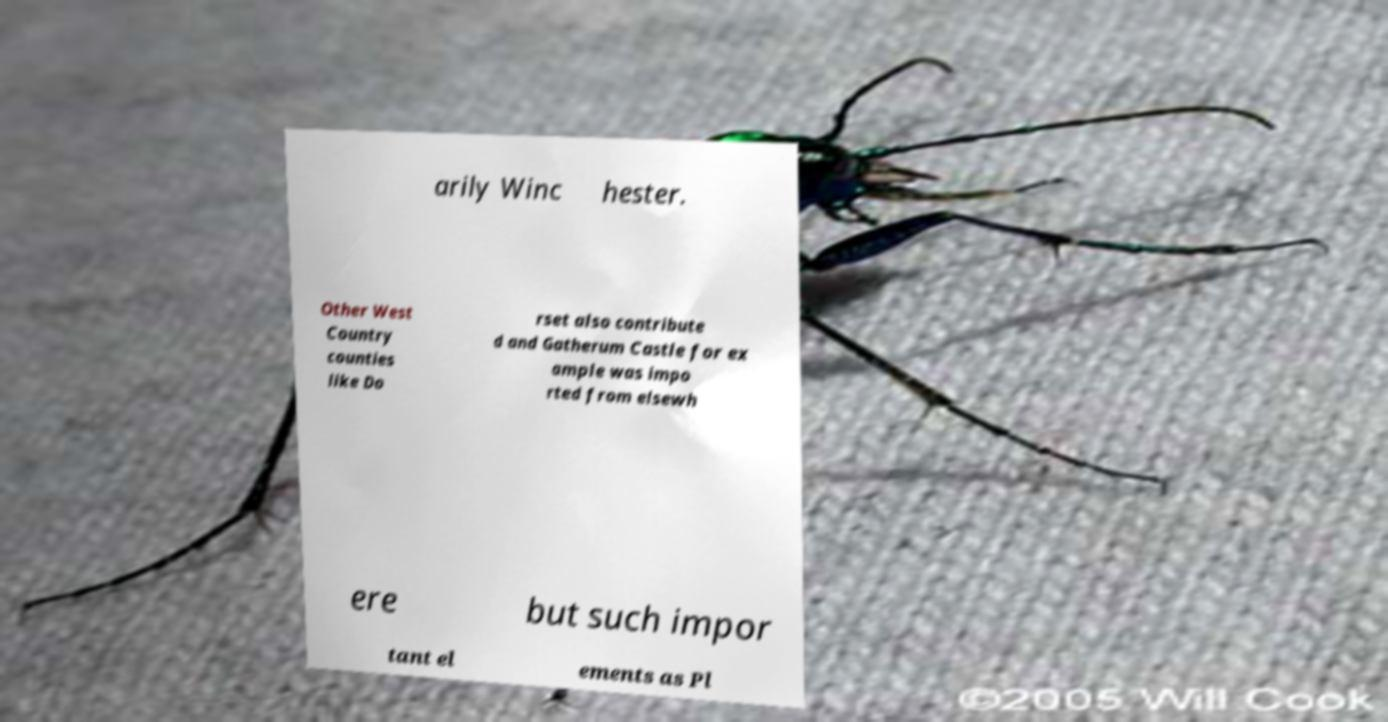Can you accurately transcribe the text from the provided image for me? arily Winc hester. Other West Country counties like Do rset also contribute d and Gatherum Castle for ex ample was impo rted from elsewh ere but such impor tant el ements as Pl 